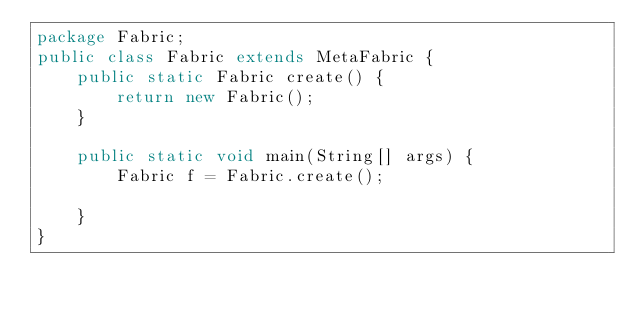Convert code to text. <code><loc_0><loc_0><loc_500><loc_500><_Java_>package Fabric;
public class Fabric extends MetaFabric {
    public static Fabric create() {
        return new Fabric();
    }

    public static void main(String[] args) {
        Fabric f = Fabric.create();

    }
}</code> 